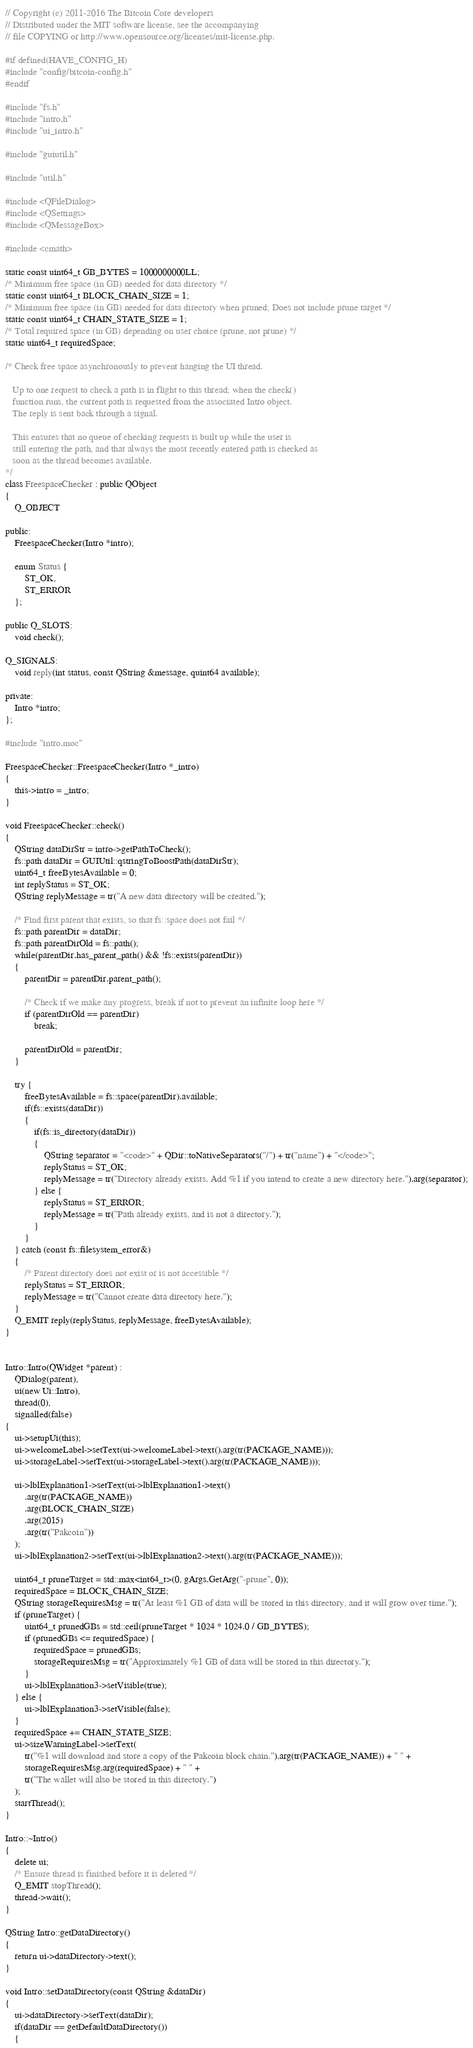<code> <loc_0><loc_0><loc_500><loc_500><_C++_>// Copyright (c) 2011-2016 The Bitcoin Core developers
// Distributed under the MIT software license, see the accompanying
// file COPYING or http://www.opensource.org/licenses/mit-license.php.

#if defined(HAVE_CONFIG_H)
#include "config/bitcoin-config.h"
#endif

#include "fs.h"
#include "intro.h"
#include "ui_intro.h"

#include "guiutil.h"

#include "util.h"

#include <QFileDialog>
#include <QSettings>
#include <QMessageBox>

#include <cmath>

static const uint64_t GB_BYTES = 1000000000LL;
/* Minimum free space (in GB) needed for data directory */
static const uint64_t BLOCK_CHAIN_SIZE = 1;
/* Minimum free space (in GB) needed for data directory when pruned; Does not include prune target */
static const uint64_t CHAIN_STATE_SIZE = 1;
/* Total required space (in GB) depending on user choice (prune, not prune) */
static uint64_t requiredSpace;

/* Check free space asynchronously to prevent hanging the UI thread.

   Up to one request to check a path is in flight to this thread; when the check()
   function runs, the current path is requested from the associated Intro object.
   The reply is sent back through a signal.

   This ensures that no queue of checking requests is built up while the user is
   still entering the path, and that always the most recently entered path is checked as
   soon as the thread becomes available.
*/
class FreespaceChecker : public QObject
{
    Q_OBJECT

public:
    FreespaceChecker(Intro *intro);

    enum Status {
        ST_OK,
        ST_ERROR
    };

public Q_SLOTS:
    void check();

Q_SIGNALS:
    void reply(int status, const QString &message, quint64 available);

private:
    Intro *intro;
};

#include "intro.moc"

FreespaceChecker::FreespaceChecker(Intro *_intro)
{
    this->intro = _intro;
}

void FreespaceChecker::check()
{
    QString dataDirStr = intro->getPathToCheck();
    fs::path dataDir = GUIUtil::qstringToBoostPath(dataDirStr);
    uint64_t freeBytesAvailable = 0;
    int replyStatus = ST_OK;
    QString replyMessage = tr("A new data directory will be created.");

    /* Find first parent that exists, so that fs::space does not fail */
    fs::path parentDir = dataDir;
    fs::path parentDirOld = fs::path();
    while(parentDir.has_parent_path() && !fs::exists(parentDir))
    {
        parentDir = parentDir.parent_path();

        /* Check if we make any progress, break if not to prevent an infinite loop here */
        if (parentDirOld == parentDir)
            break;

        parentDirOld = parentDir;
    }

    try {
        freeBytesAvailable = fs::space(parentDir).available;
        if(fs::exists(dataDir))
        {
            if(fs::is_directory(dataDir))
            {
                QString separator = "<code>" + QDir::toNativeSeparators("/") + tr("name") + "</code>";
                replyStatus = ST_OK;
                replyMessage = tr("Directory already exists. Add %1 if you intend to create a new directory here.").arg(separator);
            } else {
                replyStatus = ST_ERROR;
                replyMessage = tr("Path already exists, and is not a directory.");
            }
        }
    } catch (const fs::filesystem_error&)
    {
        /* Parent directory does not exist or is not accessible */
        replyStatus = ST_ERROR;
        replyMessage = tr("Cannot create data directory here.");
    }
    Q_EMIT reply(replyStatus, replyMessage, freeBytesAvailable);
}


Intro::Intro(QWidget *parent) :
    QDialog(parent),
    ui(new Ui::Intro),
    thread(0),
    signalled(false)
{
    ui->setupUi(this);
    ui->welcomeLabel->setText(ui->welcomeLabel->text().arg(tr(PACKAGE_NAME)));
    ui->storageLabel->setText(ui->storageLabel->text().arg(tr(PACKAGE_NAME)));

    ui->lblExplanation1->setText(ui->lblExplanation1->text()
        .arg(tr(PACKAGE_NAME))
        .arg(BLOCK_CHAIN_SIZE)
        .arg(2015)
        .arg(tr("Pakcoin"))
    );
    ui->lblExplanation2->setText(ui->lblExplanation2->text().arg(tr(PACKAGE_NAME)));

    uint64_t pruneTarget = std::max<int64_t>(0, gArgs.GetArg("-prune", 0));
    requiredSpace = BLOCK_CHAIN_SIZE;
    QString storageRequiresMsg = tr("At least %1 GB of data will be stored in this directory, and it will grow over time.");
    if (pruneTarget) {
        uint64_t prunedGBs = std::ceil(pruneTarget * 1024 * 1024.0 / GB_BYTES);
        if (prunedGBs <= requiredSpace) {
            requiredSpace = prunedGBs;
            storageRequiresMsg = tr("Approximately %1 GB of data will be stored in this directory.");
        }
        ui->lblExplanation3->setVisible(true);
    } else {
        ui->lblExplanation3->setVisible(false);
    }
    requiredSpace += CHAIN_STATE_SIZE;
    ui->sizeWarningLabel->setText(
        tr("%1 will download and store a copy of the Pakcoin block chain.").arg(tr(PACKAGE_NAME)) + " " +
        storageRequiresMsg.arg(requiredSpace) + " " +
        tr("The wallet will also be stored in this directory.")
    );
    startThread();
}

Intro::~Intro()
{
    delete ui;
    /* Ensure thread is finished before it is deleted */
    Q_EMIT stopThread();
    thread->wait();
}

QString Intro::getDataDirectory()
{
    return ui->dataDirectory->text();
}

void Intro::setDataDirectory(const QString &dataDir)
{
    ui->dataDirectory->setText(dataDir);
    if(dataDir == getDefaultDataDirectory())
    {</code> 